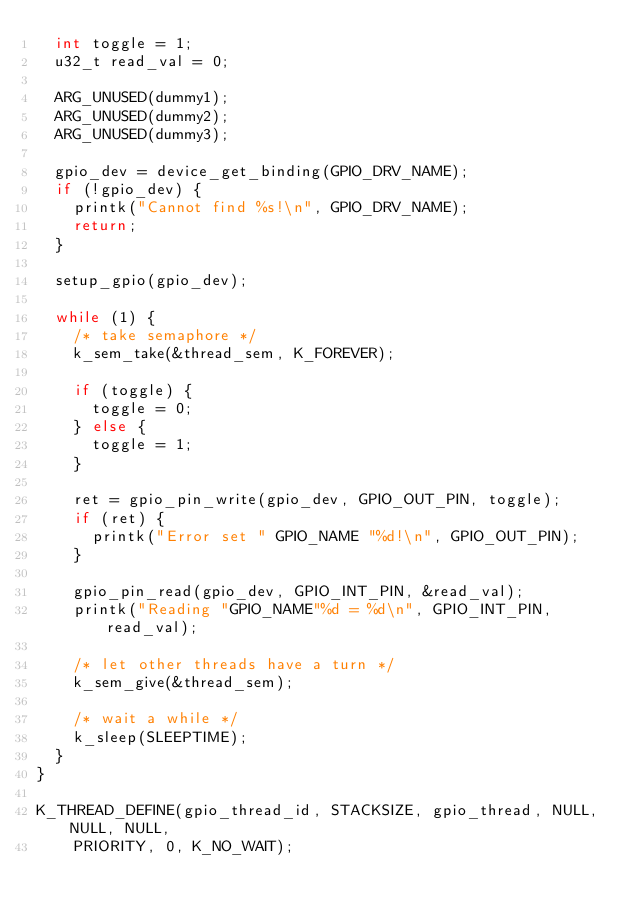Convert code to text. <code><loc_0><loc_0><loc_500><loc_500><_C_>	int toggle = 1;
	u32_t read_val = 0;

	ARG_UNUSED(dummy1);
	ARG_UNUSED(dummy2);
	ARG_UNUSED(dummy3);

	gpio_dev = device_get_binding(GPIO_DRV_NAME);
	if (!gpio_dev) {
		printk("Cannot find %s!\n", GPIO_DRV_NAME);
		return;
	}

	setup_gpio(gpio_dev);

	while (1) {
		/* take semaphore */
		k_sem_take(&thread_sem, K_FOREVER);

		if (toggle) {
			toggle = 0;
		} else {
			toggle = 1;
		}

		ret = gpio_pin_write(gpio_dev, GPIO_OUT_PIN, toggle);
		if (ret) {
			printk("Error set " GPIO_NAME "%d!\n", GPIO_OUT_PIN);
		}

		gpio_pin_read(gpio_dev, GPIO_INT_PIN, &read_val);
		printk("Reading "GPIO_NAME"%d = %d\n", GPIO_INT_PIN, read_val);

		/* let other threads have a turn */
		k_sem_give(&thread_sem);

		/* wait a while */
		k_sleep(SLEEPTIME);
	}
}

K_THREAD_DEFINE(gpio_thread_id, STACKSIZE, gpio_thread, NULL, NULL, NULL,
		PRIORITY, 0, K_NO_WAIT);
</code> 